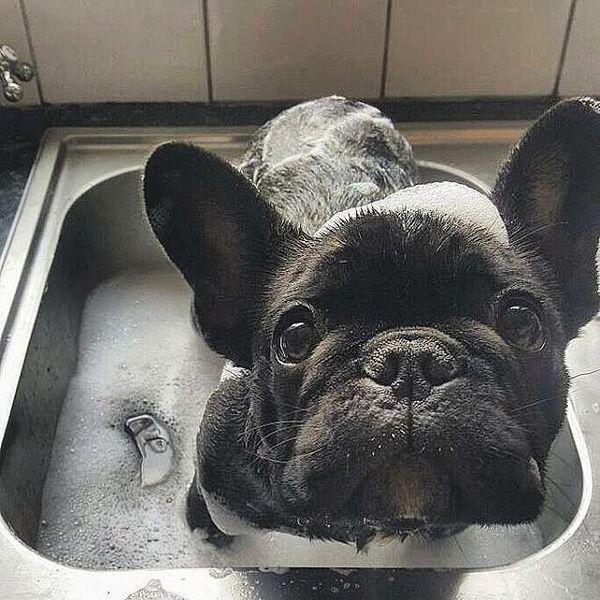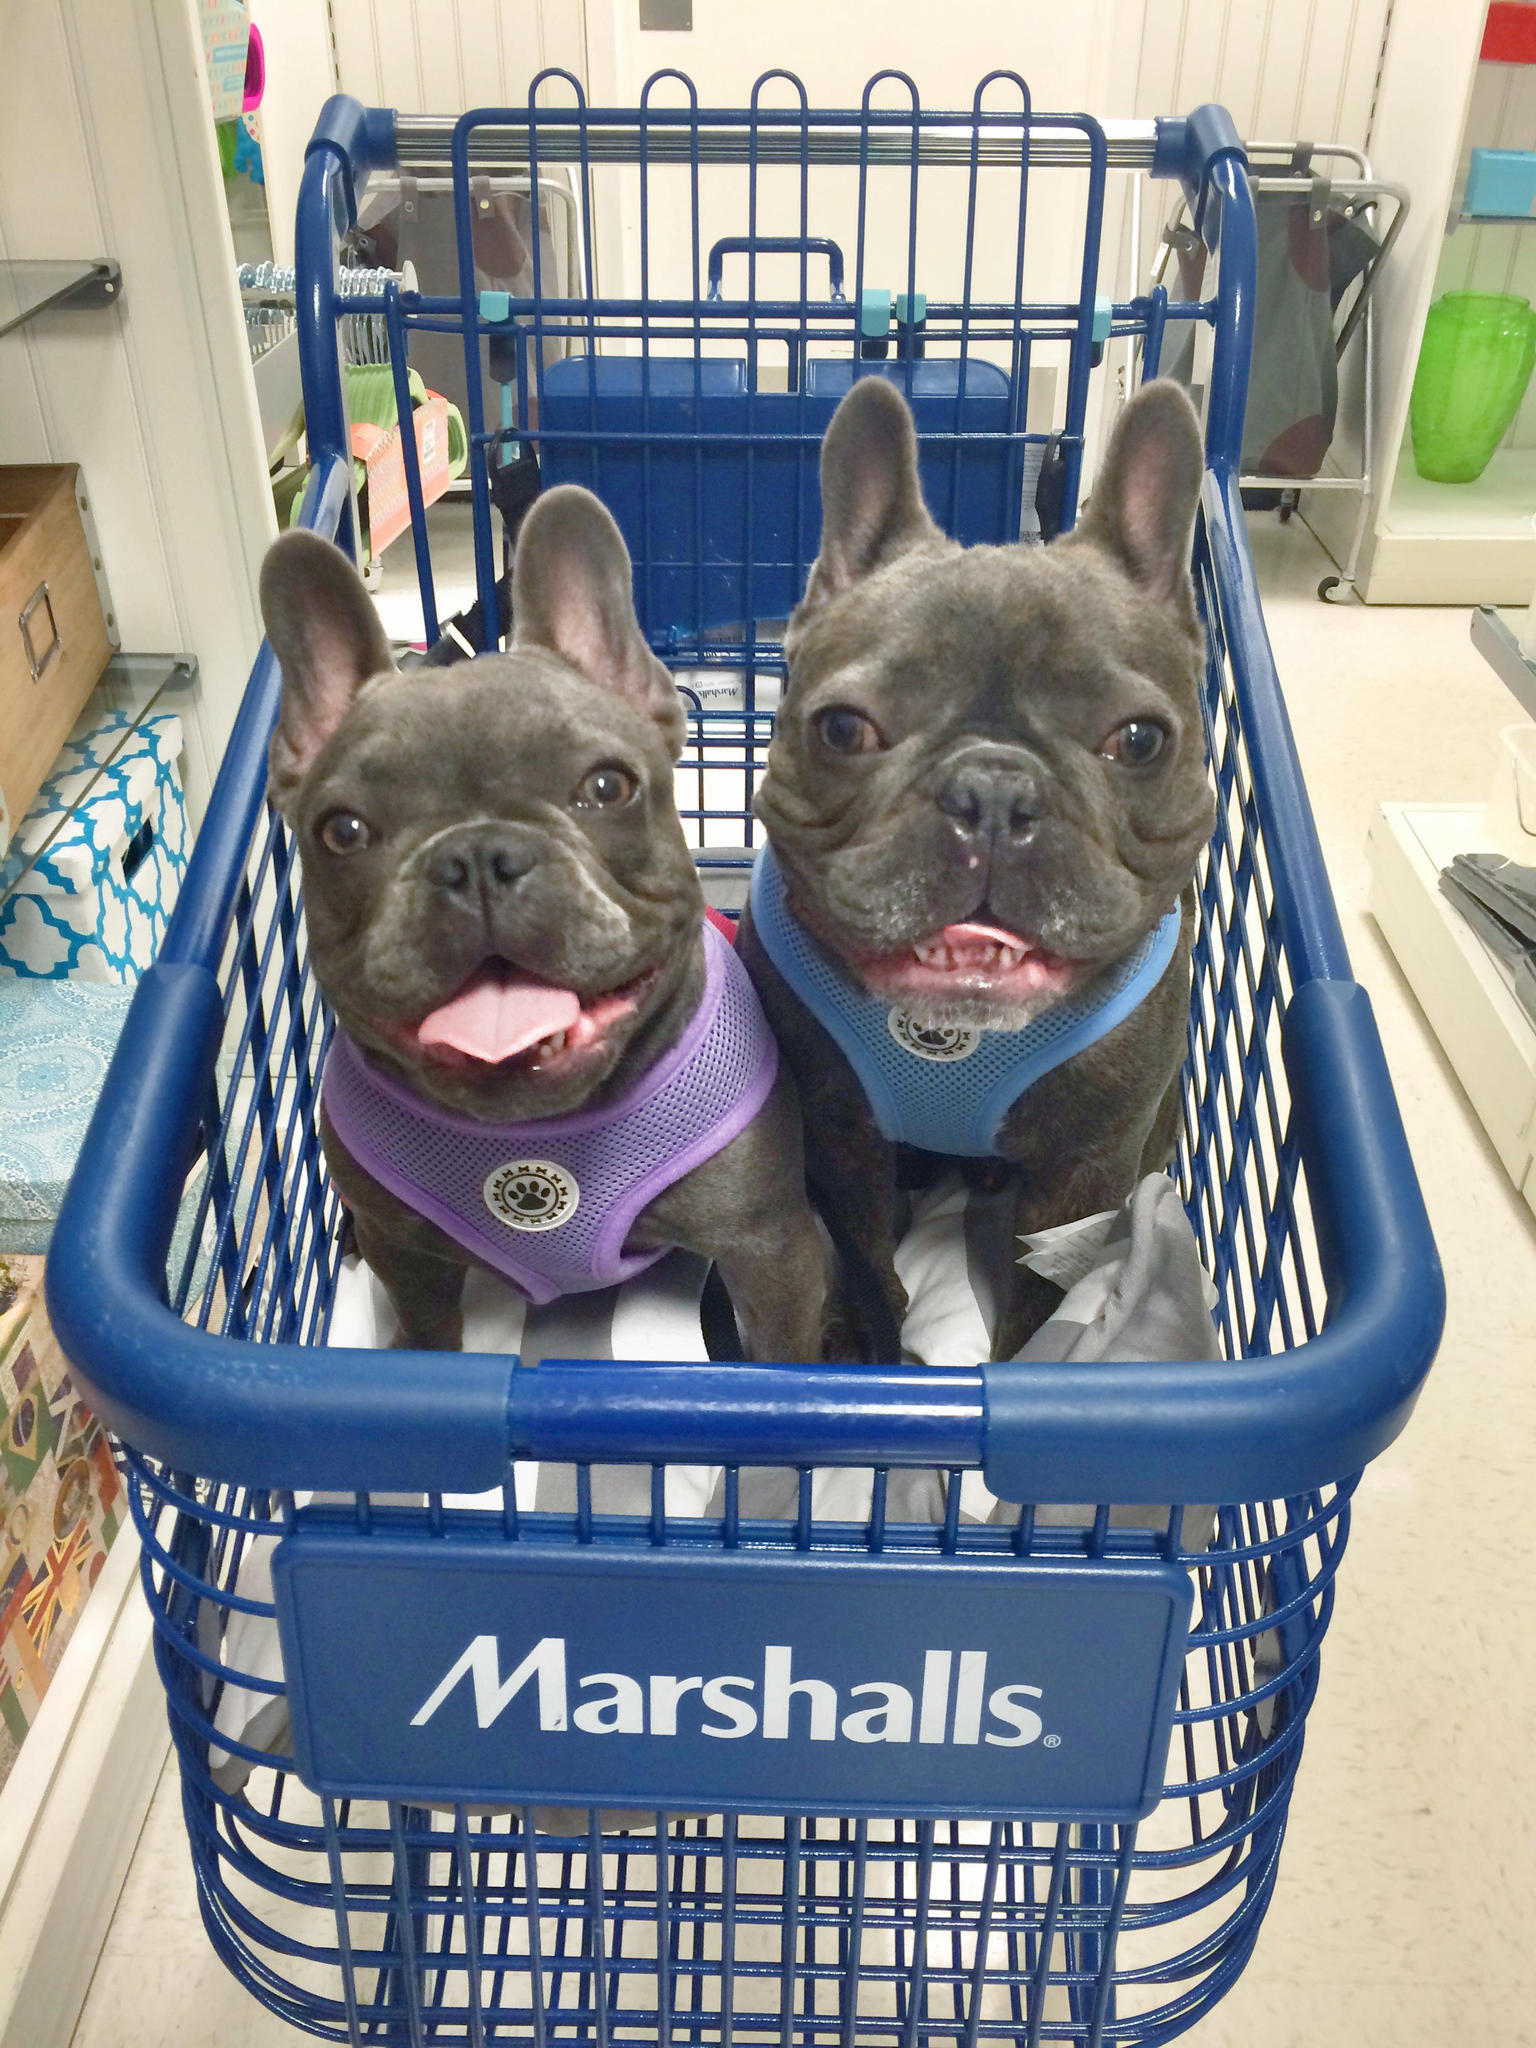The first image is the image on the left, the second image is the image on the right. For the images shown, is this caption "Two puppies are inside a shopping cart." true? Answer yes or no. Yes. The first image is the image on the left, the second image is the image on the right. Considering the images on both sides, is "A dark dog is wearing a blue vest and is inside of a shopping cart." valid? Answer yes or no. Yes. 